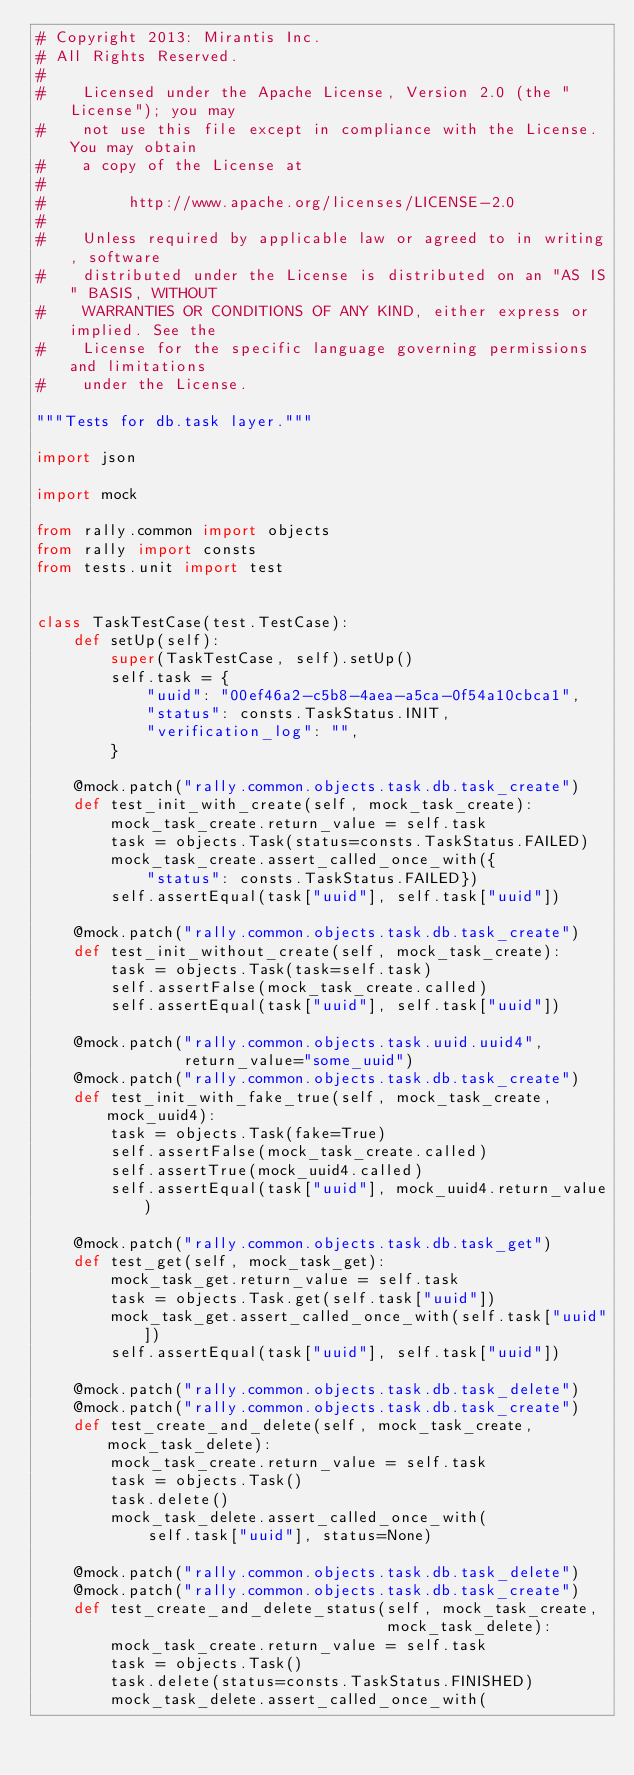<code> <loc_0><loc_0><loc_500><loc_500><_Python_># Copyright 2013: Mirantis Inc.
# All Rights Reserved.
#
#    Licensed under the Apache License, Version 2.0 (the "License"); you may
#    not use this file except in compliance with the License. You may obtain
#    a copy of the License at
#
#         http://www.apache.org/licenses/LICENSE-2.0
#
#    Unless required by applicable law or agreed to in writing, software
#    distributed under the License is distributed on an "AS IS" BASIS, WITHOUT
#    WARRANTIES OR CONDITIONS OF ANY KIND, either express or implied. See the
#    License for the specific language governing permissions and limitations
#    under the License.

"""Tests for db.task layer."""

import json

import mock

from rally.common import objects
from rally import consts
from tests.unit import test


class TaskTestCase(test.TestCase):
    def setUp(self):
        super(TaskTestCase, self).setUp()
        self.task = {
            "uuid": "00ef46a2-c5b8-4aea-a5ca-0f54a10cbca1",
            "status": consts.TaskStatus.INIT,
            "verification_log": "",
        }

    @mock.patch("rally.common.objects.task.db.task_create")
    def test_init_with_create(self, mock_task_create):
        mock_task_create.return_value = self.task
        task = objects.Task(status=consts.TaskStatus.FAILED)
        mock_task_create.assert_called_once_with({
            "status": consts.TaskStatus.FAILED})
        self.assertEqual(task["uuid"], self.task["uuid"])

    @mock.patch("rally.common.objects.task.db.task_create")
    def test_init_without_create(self, mock_task_create):
        task = objects.Task(task=self.task)
        self.assertFalse(mock_task_create.called)
        self.assertEqual(task["uuid"], self.task["uuid"])

    @mock.patch("rally.common.objects.task.uuid.uuid4",
                return_value="some_uuid")
    @mock.patch("rally.common.objects.task.db.task_create")
    def test_init_with_fake_true(self, mock_task_create, mock_uuid4):
        task = objects.Task(fake=True)
        self.assertFalse(mock_task_create.called)
        self.assertTrue(mock_uuid4.called)
        self.assertEqual(task["uuid"], mock_uuid4.return_value)

    @mock.patch("rally.common.objects.task.db.task_get")
    def test_get(self, mock_task_get):
        mock_task_get.return_value = self.task
        task = objects.Task.get(self.task["uuid"])
        mock_task_get.assert_called_once_with(self.task["uuid"])
        self.assertEqual(task["uuid"], self.task["uuid"])

    @mock.patch("rally.common.objects.task.db.task_delete")
    @mock.patch("rally.common.objects.task.db.task_create")
    def test_create_and_delete(self, mock_task_create, mock_task_delete):
        mock_task_create.return_value = self.task
        task = objects.Task()
        task.delete()
        mock_task_delete.assert_called_once_with(
            self.task["uuid"], status=None)

    @mock.patch("rally.common.objects.task.db.task_delete")
    @mock.patch("rally.common.objects.task.db.task_create")
    def test_create_and_delete_status(self, mock_task_create,
                                      mock_task_delete):
        mock_task_create.return_value = self.task
        task = objects.Task()
        task.delete(status=consts.TaskStatus.FINISHED)
        mock_task_delete.assert_called_once_with(</code> 